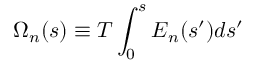<formula> <loc_0><loc_0><loc_500><loc_500>\Omega _ { n } ( s ) \equiv T \int _ { 0 } ^ { s } E _ { n } ( s ^ { \prime } ) d s ^ { \prime }</formula> 